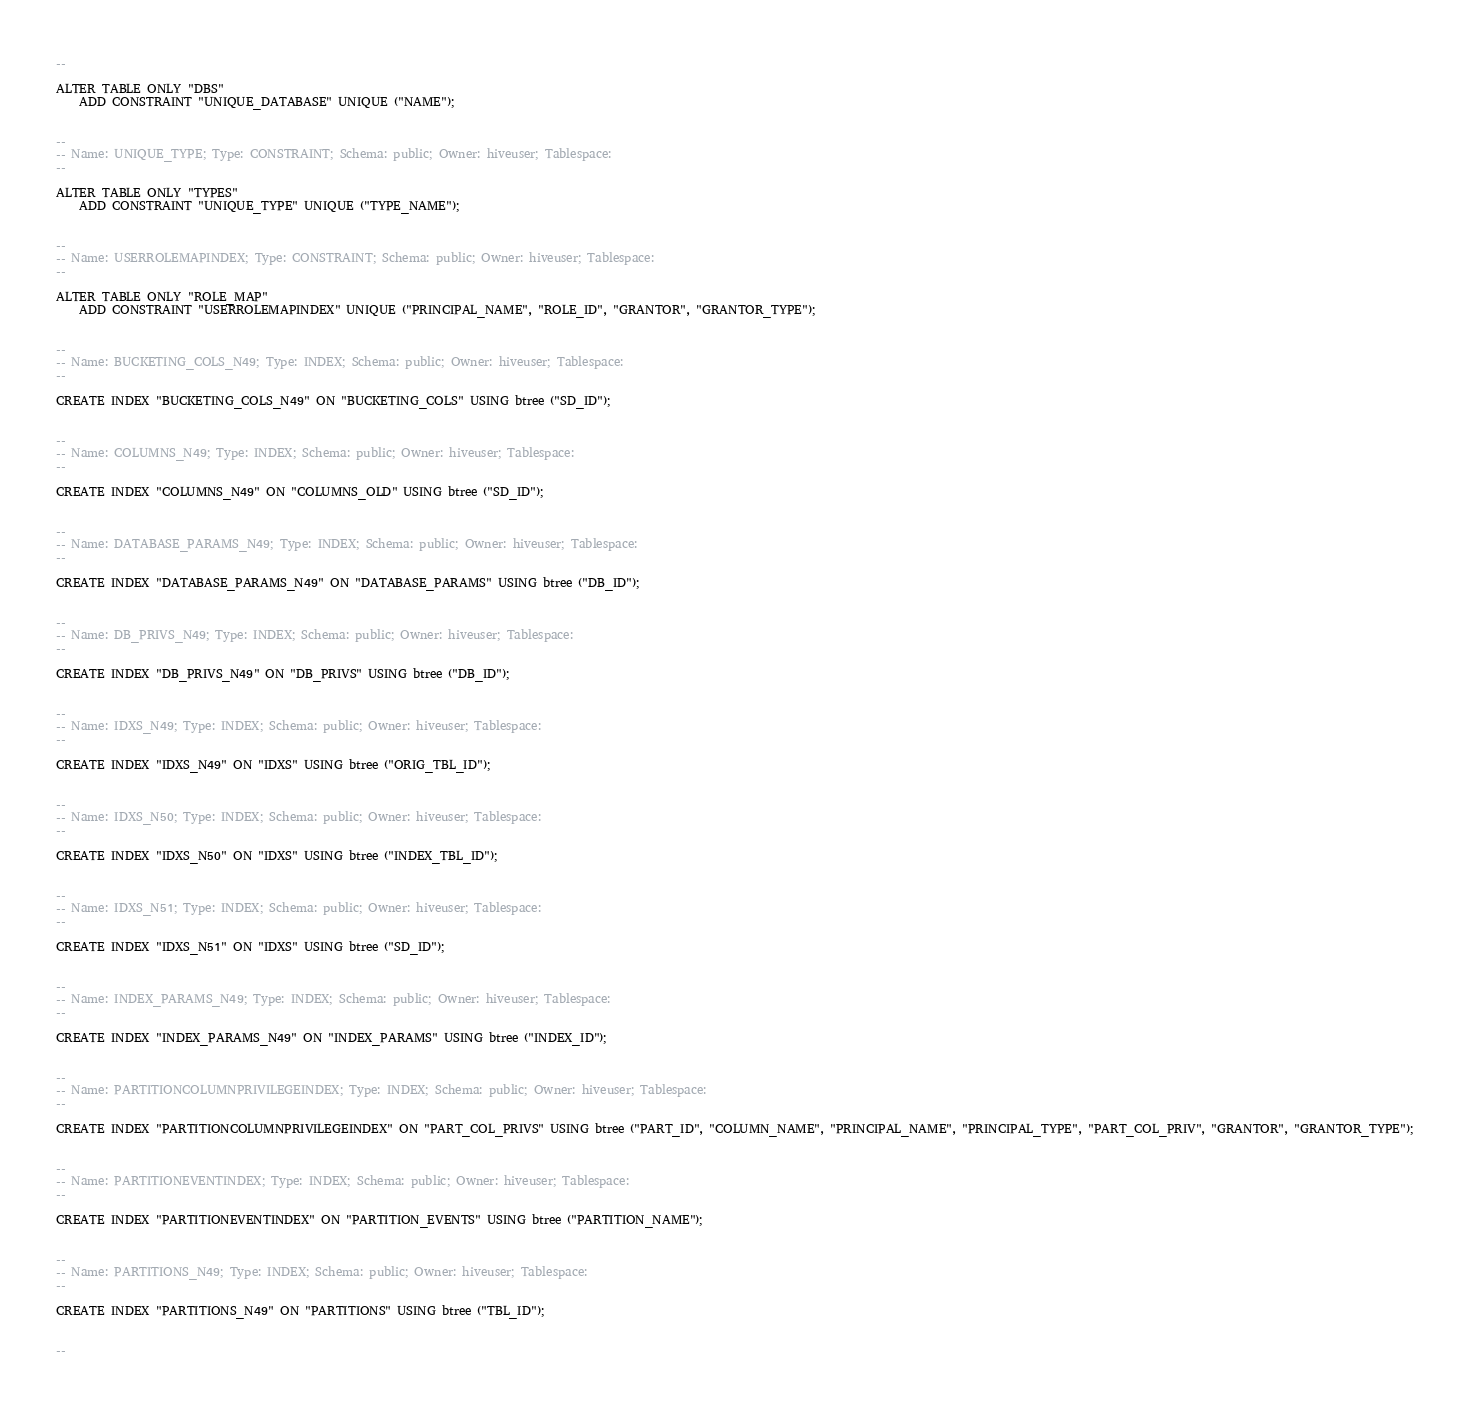<code> <loc_0><loc_0><loc_500><loc_500><_SQL_>--

ALTER TABLE ONLY "DBS"
    ADD CONSTRAINT "UNIQUE_DATABASE" UNIQUE ("NAME");


--
-- Name: UNIQUE_TYPE; Type: CONSTRAINT; Schema: public; Owner: hiveuser; Tablespace:
--

ALTER TABLE ONLY "TYPES"
    ADD CONSTRAINT "UNIQUE_TYPE" UNIQUE ("TYPE_NAME");


--
-- Name: USERROLEMAPINDEX; Type: CONSTRAINT; Schema: public; Owner: hiveuser; Tablespace:
--

ALTER TABLE ONLY "ROLE_MAP"
    ADD CONSTRAINT "USERROLEMAPINDEX" UNIQUE ("PRINCIPAL_NAME", "ROLE_ID", "GRANTOR", "GRANTOR_TYPE");


--
-- Name: BUCKETING_COLS_N49; Type: INDEX; Schema: public; Owner: hiveuser; Tablespace:
--

CREATE INDEX "BUCKETING_COLS_N49" ON "BUCKETING_COLS" USING btree ("SD_ID");


--
-- Name: COLUMNS_N49; Type: INDEX; Schema: public; Owner: hiveuser; Tablespace:
--

CREATE INDEX "COLUMNS_N49" ON "COLUMNS_OLD" USING btree ("SD_ID");


--
-- Name: DATABASE_PARAMS_N49; Type: INDEX; Schema: public; Owner: hiveuser; Tablespace:
--

CREATE INDEX "DATABASE_PARAMS_N49" ON "DATABASE_PARAMS" USING btree ("DB_ID");


--
-- Name: DB_PRIVS_N49; Type: INDEX; Schema: public; Owner: hiveuser; Tablespace:
--

CREATE INDEX "DB_PRIVS_N49" ON "DB_PRIVS" USING btree ("DB_ID");


--
-- Name: IDXS_N49; Type: INDEX; Schema: public; Owner: hiveuser; Tablespace:
--

CREATE INDEX "IDXS_N49" ON "IDXS" USING btree ("ORIG_TBL_ID");


--
-- Name: IDXS_N50; Type: INDEX; Schema: public; Owner: hiveuser; Tablespace:
--

CREATE INDEX "IDXS_N50" ON "IDXS" USING btree ("INDEX_TBL_ID");


--
-- Name: IDXS_N51; Type: INDEX; Schema: public; Owner: hiveuser; Tablespace:
--

CREATE INDEX "IDXS_N51" ON "IDXS" USING btree ("SD_ID");


--
-- Name: INDEX_PARAMS_N49; Type: INDEX; Schema: public; Owner: hiveuser; Tablespace:
--

CREATE INDEX "INDEX_PARAMS_N49" ON "INDEX_PARAMS" USING btree ("INDEX_ID");


--
-- Name: PARTITIONCOLUMNPRIVILEGEINDEX; Type: INDEX; Schema: public; Owner: hiveuser; Tablespace:
--

CREATE INDEX "PARTITIONCOLUMNPRIVILEGEINDEX" ON "PART_COL_PRIVS" USING btree ("PART_ID", "COLUMN_NAME", "PRINCIPAL_NAME", "PRINCIPAL_TYPE", "PART_COL_PRIV", "GRANTOR", "GRANTOR_TYPE");


--
-- Name: PARTITIONEVENTINDEX; Type: INDEX; Schema: public; Owner: hiveuser; Tablespace:
--

CREATE INDEX "PARTITIONEVENTINDEX" ON "PARTITION_EVENTS" USING btree ("PARTITION_NAME");


--
-- Name: PARTITIONS_N49; Type: INDEX; Schema: public; Owner: hiveuser; Tablespace:
--

CREATE INDEX "PARTITIONS_N49" ON "PARTITIONS" USING btree ("TBL_ID");


--</code> 